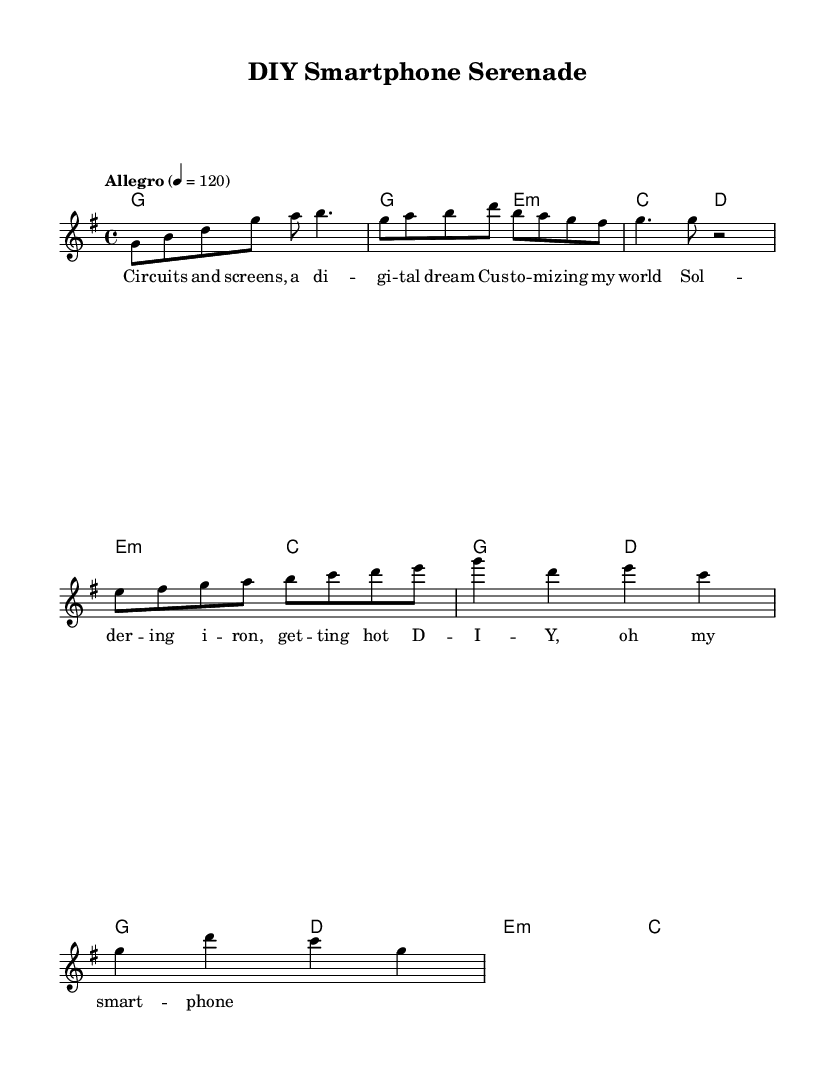What key is this music in? The key signature is indicated at the beginning of the sheet music. It shows a "G" with one sharp, meaning the key is G major.
Answer: G major What is the time signature of this piece? The time signature is found at the beginning of the sheet music, displayed as "4/4," indicating it has four beats per measure and a quarter note receives one beat.
Answer: 4/4 What is the tempo marking for this piece? The tempo indication is also located at the start and is marked "Allegro," with a metronome mark of 4 = 120, suggesting a lively pace.
Answer: Allegro How many measures are there in the chorus? By counting the measures in the chorus section of the music, we find that there are four measures, divided by the bar lines in that section.
Answer: 4 What is the primary theme of this piece? By analyzing the lyrics provided in conjunction with the title "DIY Smartphone Serenade," we can see that the song is about customizing and building smartphones, reflecting a DIY theme.
Answer: Customizing smartphones What is the first note of the verse? Looking at the melody for the verse section, the first note is "G," which appears to be represented as the first note in that part of the melody.
Answer: G What musical technique is mentioned in the pre-chorus? The pre-chorus lyrics mention "Soldering iron," which indicates a technique used in assembling and customizing electronics, relevant to the DIY theme.
Answer: Soldering 